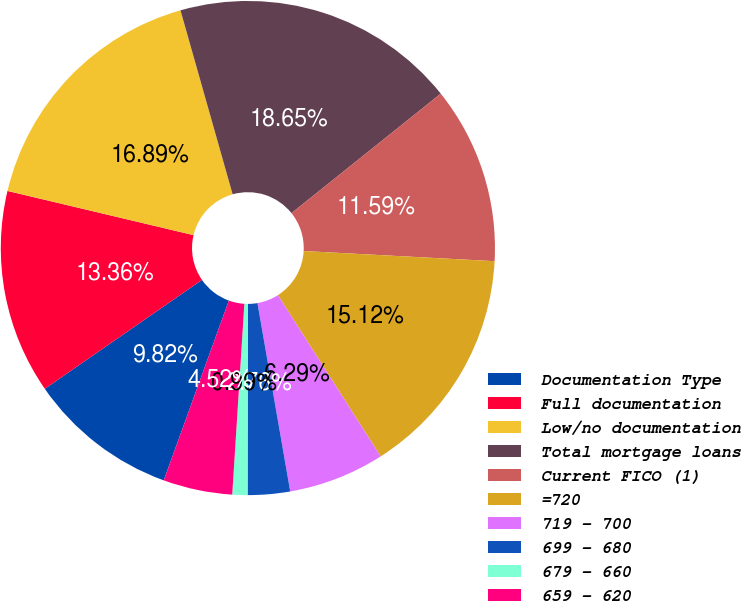Convert chart. <chart><loc_0><loc_0><loc_500><loc_500><pie_chart><fcel>Documentation Type<fcel>Full documentation<fcel>Low/no documentation<fcel>Total mortgage loans<fcel>Current FICO (1)<fcel>=720<fcel>719 - 700<fcel>699 - 680<fcel>679 - 660<fcel>659 - 620<nl><fcel>9.82%<fcel>13.36%<fcel>16.89%<fcel>18.65%<fcel>11.59%<fcel>15.12%<fcel>6.29%<fcel>2.76%<fcel>0.99%<fcel>4.52%<nl></chart> 